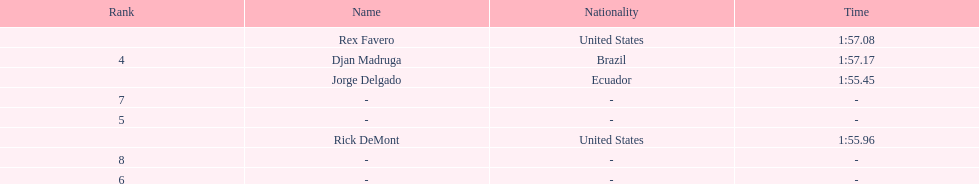What is the usual time span? 1:56.42. 